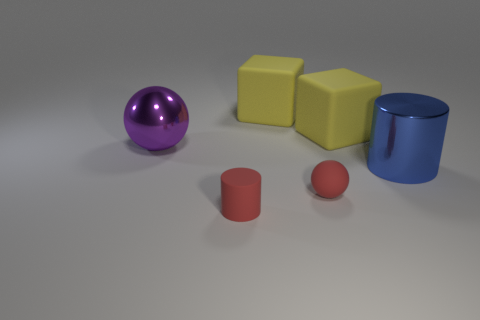How do the objects appear in terms of lighting and shadows? The objects are evenly lit with soft shadows indicating a diffuse light source. The direction of the shadows suggests a light source coming from the upper left side, likely out of frame. The shadows help give depth to the objects and enhance the three-dimensional aspect of the scene. 